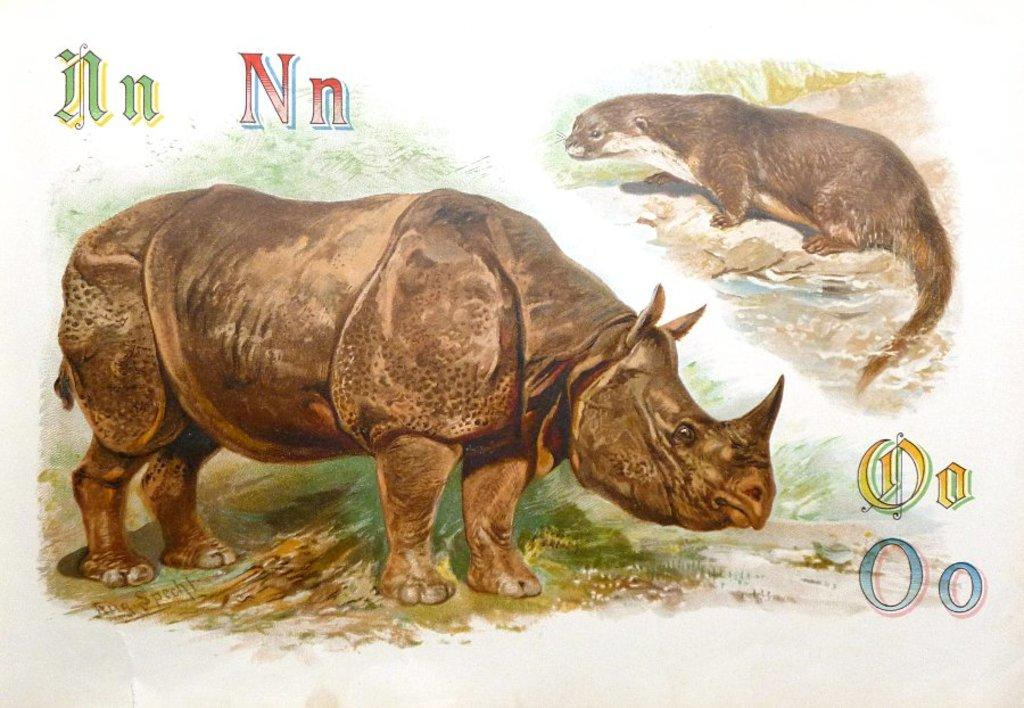What is featured on the poster in the image? There is a poster in the image, and it has an image of a rhinoceros. Can you describe the type of image on the poster? The poster has an image of an animal, specifically a rhinoceros. Is there any text on the poster? Yes, there is text on the poster. How many pizzas are shown on the poster? There are no pizzas shown on the poster; it features an image of a rhinoceros and has text. What type of map is depicted on the poster? There is no map present on the poster; it features an image of a rhinoceros and has text. 